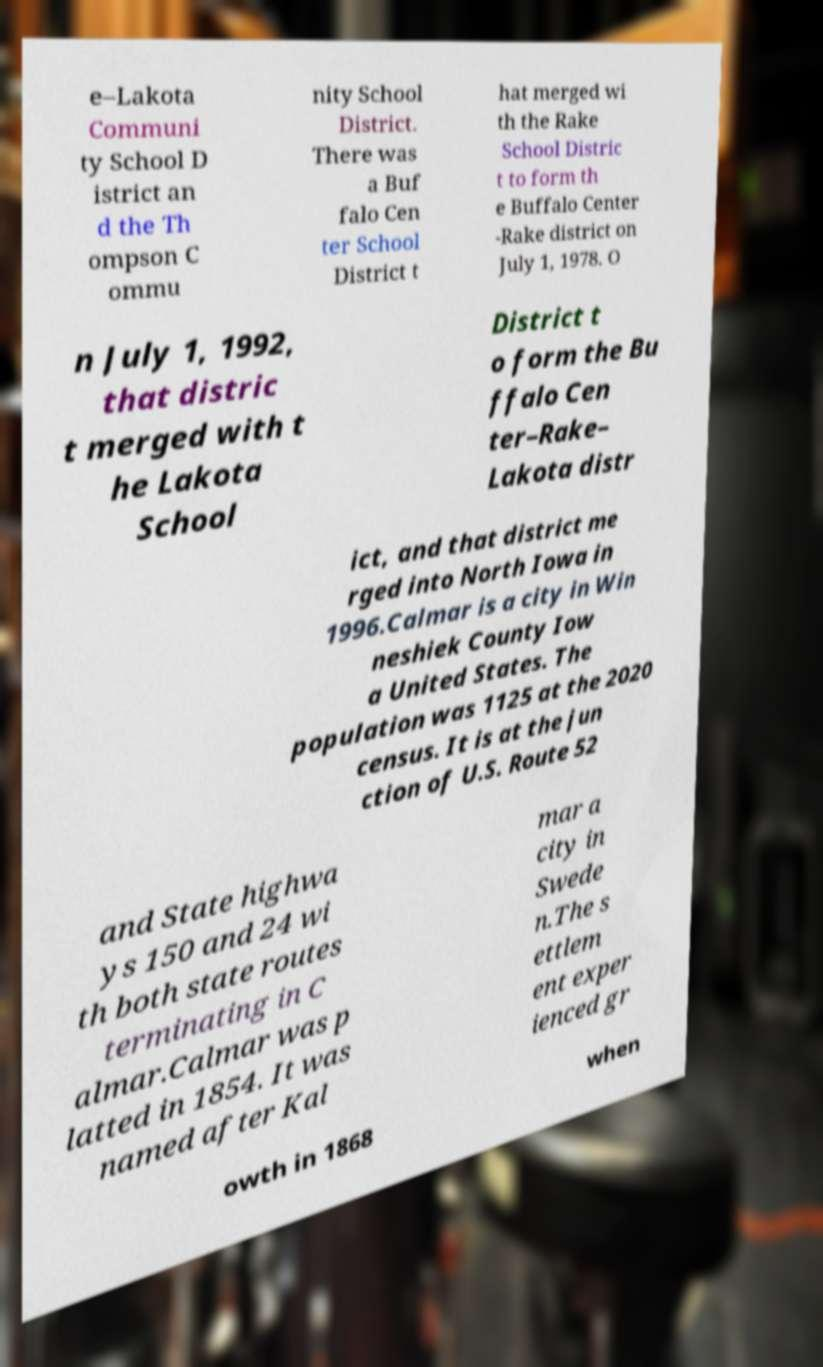What messages or text are displayed in this image? I need them in a readable, typed format. e–Lakota Communi ty School D istrict an d the Th ompson C ommu nity School District. There was a Buf falo Cen ter School District t hat merged wi th the Rake School Distric t to form th e Buffalo Center -Rake district on July 1, 1978. O n July 1, 1992, that distric t merged with t he Lakota School District t o form the Bu ffalo Cen ter–Rake– Lakota distr ict, and that district me rged into North Iowa in 1996.Calmar is a city in Win neshiek County Iow a United States. The population was 1125 at the 2020 census. It is at the jun ction of U.S. Route 52 and State highwa ys 150 and 24 wi th both state routes terminating in C almar.Calmar was p latted in 1854. It was named after Kal mar a city in Swede n.The s ettlem ent exper ienced gr owth in 1868 when 